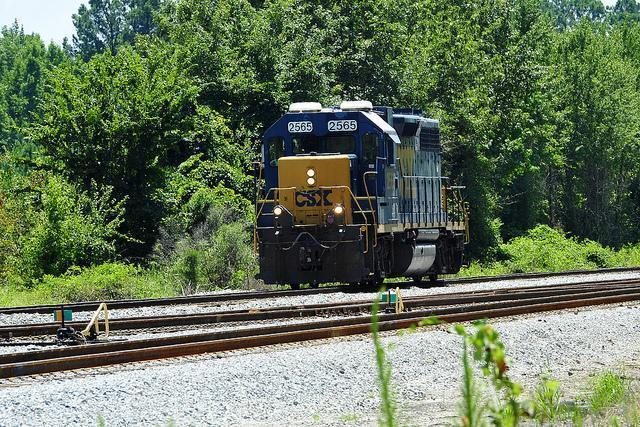How many rail tracks are there?
Give a very brief answer. 2. How many lights are on the train?
Give a very brief answer. 4. 